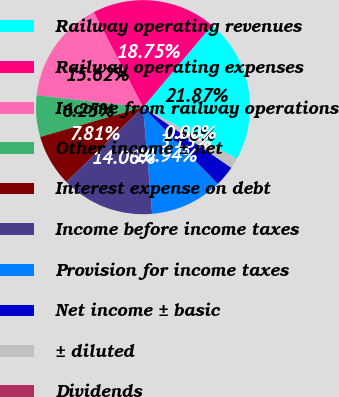Convert chart to OTSL. <chart><loc_0><loc_0><loc_500><loc_500><pie_chart><fcel>Railway operating revenues<fcel>Railway operating expenses<fcel>Income from railway operations<fcel>Other income ± net<fcel>Interest expense on debt<fcel>Income before income taxes<fcel>Provision for income taxes<fcel>Net income ± basic<fcel>± diluted<fcel>Dividends<nl><fcel>21.87%<fcel>18.75%<fcel>15.62%<fcel>6.25%<fcel>7.81%<fcel>14.06%<fcel>10.94%<fcel>3.13%<fcel>1.56%<fcel>0.0%<nl></chart> 